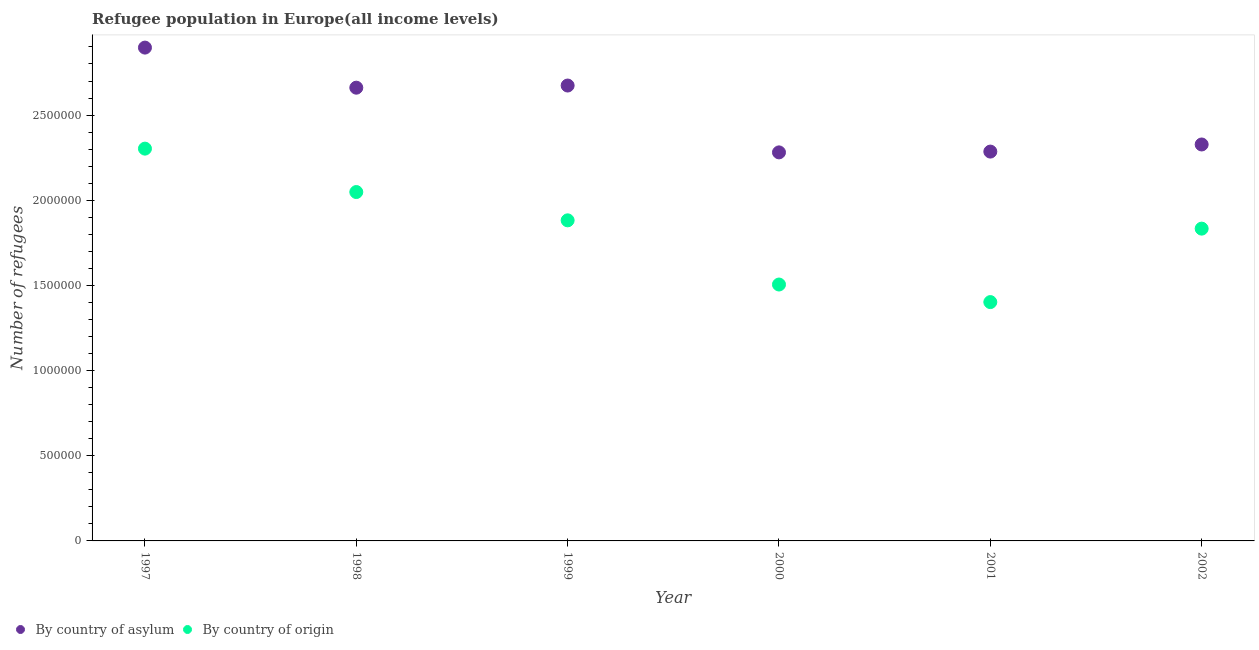What is the number of refugees by country of asylum in 1997?
Provide a short and direct response. 2.90e+06. Across all years, what is the maximum number of refugees by country of asylum?
Offer a very short reply. 2.90e+06. Across all years, what is the minimum number of refugees by country of origin?
Keep it short and to the point. 1.40e+06. What is the total number of refugees by country of origin in the graph?
Provide a short and direct response. 1.10e+07. What is the difference between the number of refugees by country of origin in 1997 and that in 2000?
Ensure brevity in your answer.  7.98e+05. What is the difference between the number of refugees by country of asylum in 2000 and the number of refugees by country of origin in 1998?
Provide a succinct answer. 2.33e+05. What is the average number of refugees by country of asylum per year?
Keep it short and to the point. 2.52e+06. In the year 2002, what is the difference between the number of refugees by country of asylum and number of refugees by country of origin?
Provide a short and direct response. 4.94e+05. In how many years, is the number of refugees by country of asylum greater than 400000?
Make the answer very short. 6. What is the ratio of the number of refugees by country of origin in 1997 to that in 2002?
Your response must be concise. 1.26. Is the difference between the number of refugees by country of asylum in 1998 and 2001 greater than the difference between the number of refugees by country of origin in 1998 and 2001?
Offer a terse response. No. What is the difference between the highest and the second highest number of refugees by country of asylum?
Your answer should be compact. 2.23e+05. What is the difference between the highest and the lowest number of refugees by country of asylum?
Offer a very short reply. 6.15e+05. In how many years, is the number of refugees by country of origin greater than the average number of refugees by country of origin taken over all years?
Ensure brevity in your answer.  4. Is the number of refugees by country of origin strictly greater than the number of refugees by country of asylum over the years?
Provide a succinct answer. No. How many dotlines are there?
Your answer should be compact. 2. How many years are there in the graph?
Keep it short and to the point. 6. What is the difference between two consecutive major ticks on the Y-axis?
Offer a very short reply. 5.00e+05. Are the values on the major ticks of Y-axis written in scientific E-notation?
Offer a terse response. No. Does the graph contain grids?
Give a very brief answer. No. How many legend labels are there?
Your answer should be compact. 2. What is the title of the graph?
Give a very brief answer. Refugee population in Europe(all income levels). Does "Stunting" appear as one of the legend labels in the graph?
Keep it short and to the point. No. What is the label or title of the X-axis?
Provide a short and direct response. Year. What is the label or title of the Y-axis?
Your answer should be compact. Number of refugees. What is the Number of refugees in By country of asylum in 1997?
Ensure brevity in your answer.  2.90e+06. What is the Number of refugees of By country of origin in 1997?
Give a very brief answer. 2.30e+06. What is the Number of refugees of By country of asylum in 1998?
Offer a terse response. 2.66e+06. What is the Number of refugees of By country of origin in 1998?
Provide a short and direct response. 2.05e+06. What is the Number of refugees in By country of asylum in 1999?
Your answer should be compact. 2.67e+06. What is the Number of refugees of By country of origin in 1999?
Offer a terse response. 1.88e+06. What is the Number of refugees in By country of asylum in 2000?
Provide a short and direct response. 2.28e+06. What is the Number of refugees in By country of origin in 2000?
Offer a very short reply. 1.51e+06. What is the Number of refugees of By country of asylum in 2001?
Give a very brief answer. 2.29e+06. What is the Number of refugees of By country of origin in 2001?
Offer a terse response. 1.40e+06. What is the Number of refugees of By country of asylum in 2002?
Ensure brevity in your answer.  2.33e+06. What is the Number of refugees in By country of origin in 2002?
Make the answer very short. 1.83e+06. Across all years, what is the maximum Number of refugees of By country of asylum?
Make the answer very short. 2.90e+06. Across all years, what is the maximum Number of refugees in By country of origin?
Your answer should be compact. 2.30e+06. Across all years, what is the minimum Number of refugees in By country of asylum?
Provide a succinct answer. 2.28e+06. Across all years, what is the minimum Number of refugees of By country of origin?
Provide a succinct answer. 1.40e+06. What is the total Number of refugees in By country of asylum in the graph?
Provide a short and direct response. 1.51e+07. What is the total Number of refugees of By country of origin in the graph?
Ensure brevity in your answer.  1.10e+07. What is the difference between the Number of refugees of By country of asylum in 1997 and that in 1998?
Offer a terse response. 2.35e+05. What is the difference between the Number of refugees in By country of origin in 1997 and that in 1998?
Your answer should be compact. 2.55e+05. What is the difference between the Number of refugees of By country of asylum in 1997 and that in 1999?
Ensure brevity in your answer.  2.23e+05. What is the difference between the Number of refugees in By country of origin in 1997 and that in 1999?
Make the answer very short. 4.21e+05. What is the difference between the Number of refugees of By country of asylum in 1997 and that in 2000?
Give a very brief answer. 6.15e+05. What is the difference between the Number of refugees of By country of origin in 1997 and that in 2000?
Offer a very short reply. 7.98e+05. What is the difference between the Number of refugees of By country of asylum in 1997 and that in 2001?
Give a very brief answer. 6.11e+05. What is the difference between the Number of refugees in By country of origin in 1997 and that in 2001?
Give a very brief answer. 9.01e+05. What is the difference between the Number of refugees of By country of asylum in 1997 and that in 2002?
Provide a short and direct response. 5.69e+05. What is the difference between the Number of refugees in By country of origin in 1997 and that in 2002?
Provide a short and direct response. 4.70e+05. What is the difference between the Number of refugees of By country of asylum in 1998 and that in 1999?
Provide a short and direct response. -1.26e+04. What is the difference between the Number of refugees of By country of origin in 1998 and that in 1999?
Your answer should be very brief. 1.66e+05. What is the difference between the Number of refugees of By country of asylum in 1998 and that in 2000?
Make the answer very short. 3.80e+05. What is the difference between the Number of refugees in By country of origin in 1998 and that in 2000?
Provide a short and direct response. 5.43e+05. What is the difference between the Number of refugees of By country of asylum in 1998 and that in 2001?
Offer a terse response. 3.75e+05. What is the difference between the Number of refugees of By country of origin in 1998 and that in 2001?
Keep it short and to the point. 6.46e+05. What is the difference between the Number of refugees of By country of asylum in 1998 and that in 2002?
Ensure brevity in your answer.  3.33e+05. What is the difference between the Number of refugees of By country of origin in 1998 and that in 2002?
Make the answer very short. 2.15e+05. What is the difference between the Number of refugees of By country of asylum in 1999 and that in 2000?
Offer a very short reply. 3.92e+05. What is the difference between the Number of refugees in By country of origin in 1999 and that in 2000?
Ensure brevity in your answer.  3.77e+05. What is the difference between the Number of refugees of By country of asylum in 1999 and that in 2001?
Your answer should be compact. 3.88e+05. What is the difference between the Number of refugees in By country of origin in 1999 and that in 2001?
Give a very brief answer. 4.80e+05. What is the difference between the Number of refugees in By country of asylum in 1999 and that in 2002?
Make the answer very short. 3.46e+05. What is the difference between the Number of refugees in By country of origin in 1999 and that in 2002?
Ensure brevity in your answer.  4.87e+04. What is the difference between the Number of refugees in By country of asylum in 2000 and that in 2001?
Give a very brief answer. -4639. What is the difference between the Number of refugees of By country of origin in 2000 and that in 2001?
Offer a terse response. 1.03e+05. What is the difference between the Number of refugees of By country of asylum in 2000 and that in 2002?
Keep it short and to the point. -4.64e+04. What is the difference between the Number of refugees of By country of origin in 2000 and that in 2002?
Give a very brief answer. -3.28e+05. What is the difference between the Number of refugees in By country of asylum in 2001 and that in 2002?
Provide a succinct answer. -4.18e+04. What is the difference between the Number of refugees of By country of origin in 2001 and that in 2002?
Your answer should be very brief. -4.31e+05. What is the difference between the Number of refugees of By country of asylum in 1997 and the Number of refugees of By country of origin in 1998?
Provide a succinct answer. 8.48e+05. What is the difference between the Number of refugees of By country of asylum in 1997 and the Number of refugees of By country of origin in 1999?
Keep it short and to the point. 1.01e+06. What is the difference between the Number of refugees of By country of asylum in 1997 and the Number of refugees of By country of origin in 2000?
Your answer should be compact. 1.39e+06. What is the difference between the Number of refugees of By country of asylum in 1997 and the Number of refugees of By country of origin in 2001?
Ensure brevity in your answer.  1.49e+06. What is the difference between the Number of refugees of By country of asylum in 1997 and the Number of refugees of By country of origin in 2002?
Your answer should be very brief. 1.06e+06. What is the difference between the Number of refugees in By country of asylum in 1998 and the Number of refugees in By country of origin in 1999?
Give a very brief answer. 7.79e+05. What is the difference between the Number of refugees of By country of asylum in 1998 and the Number of refugees of By country of origin in 2000?
Make the answer very short. 1.16e+06. What is the difference between the Number of refugees in By country of asylum in 1998 and the Number of refugees in By country of origin in 2001?
Give a very brief answer. 1.26e+06. What is the difference between the Number of refugees of By country of asylum in 1998 and the Number of refugees of By country of origin in 2002?
Offer a terse response. 8.28e+05. What is the difference between the Number of refugees in By country of asylum in 1999 and the Number of refugees in By country of origin in 2000?
Offer a very short reply. 1.17e+06. What is the difference between the Number of refugees of By country of asylum in 1999 and the Number of refugees of By country of origin in 2001?
Your answer should be compact. 1.27e+06. What is the difference between the Number of refugees in By country of asylum in 1999 and the Number of refugees in By country of origin in 2002?
Give a very brief answer. 8.40e+05. What is the difference between the Number of refugees in By country of asylum in 2000 and the Number of refugees in By country of origin in 2001?
Offer a very short reply. 8.79e+05. What is the difference between the Number of refugees in By country of asylum in 2000 and the Number of refugees in By country of origin in 2002?
Give a very brief answer. 4.48e+05. What is the difference between the Number of refugees in By country of asylum in 2001 and the Number of refugees in By country of origin in 2002?
Your response must be concise. 4.52e+05. What is the average Number of refugees of By country of asylum per year?
Offer a terse response. 2.52e+06. What is the average Number of refugees of By country of origin per year?
Give a very brief answer. 1.83e+06. In the year 1997, what is the difference between the Number of refugees of By country of asylum and Number of refugees of By country of origin?
Your answer should be compact. 5.93e+05. In the year 1998, what is the difference between the Number of refugees in By country of asylum and Number of refugees in By country of origin?
Ensure brevity in your answer.  6.13e+05. In the year 1999, what is the difference between the Number of refugees of By country of asylum and Number of refugees of By country of origin?
Keep it short and to the point. 7.91e+05. In the year 2000, what is the difference between the Number of refugees in By country of asylum and Number of refugees in By country of origin?
Provide a short and direct response. 7.76e+05. In the year 2001, what is the difference between the Number of refugees of By country of asylum and Number of refugees of By country of origin?
Make the answer very short. 8.84e+05. In the year 2002, what is the difference between the Number of refugees in By country of asylum and Number of refugees in By country of origin?
Keep it short and to the point. 4.94e+05. What is the ratio of the Number of refugees in By country of asylum in 1997 to that in 1998?
Give a very brief answer. 1.09. What is the ratio of the Number of refugees in By country of origin in 1997 to that in 1998?
Give a very brief answer. 1.12. What is the ratio of the Number of refugees of By country of origin in 1997 to that in 1999?
Provide a succinct answer. 1.22. What is the ratio of the Number of refugees of By country of asylum in 1997 to that in 2000?
Your answer should be compact. 1.27. What is the ratio of the Number of refugees of By country of origin in 1997 to that in 2000?
Offer a terse response. 1.53. What is the ratio of the Number of refugees in By country of asylum in 1997 to that in 2001?
Your answer should be compact. 1.27. What is the ratio of the Number of refugees of By country of origin in 1997 to that in 2001?
Give a very brief answer. 1.64. What is the ratio of the Number of refugees of By country of asylum in 1997 to that in 2002?
Your answer should be compact. 1.24. What is the ratio of the Number of refugees of By country of origin in 1997 to that in 2002?
Offer a terse response. 1.26. What is the ratio of the Number of refugees in By country of asylum in 1998 to that in 1999?
Offer a very short reply. 1. What is the ratio of the Number of refugees of By country of origin in 1998 to that in 1999?
Provide a short and direct response. 1.09. What is the ratio of the Number of refugees in By country of asylum in 1998 to that in 2000?
Ensure brevity in your answer.  1.17. What is the ratio of the Number of refugees in By country of origin in 1998 to that in 2000?
Offer a terse response. 1.36. What is the ratio of the Number of refugees of By country of asylum in 1998 to that in 2001?
Keep it short and to the point. 1.16. What is the ratio of the Number of refugees in By country of origin in 1998 to that in 2001?
Keep it short and to the point. 1.46. What is the ratio of the Number of refugees of By country of asylum in 1998 to that in 2002?
Your answer should be compact. 1.14. What is the ratio of the Number of refugees of By country of origin in 1998 to that in 2002?
Your response must be concise. 1.12. What is the ratio of the Number of refugees of By country of asylum in 1999 to that in 2000?
Provide a succinct answer. 1.17. What is the ratio of the Number of refugees of By country of origin in 1999 to that in 2000?
Provide a short and direct response. 1.25. What is the ratio of the Number of refugees of By country of asylum in 1999 to that in 2001?
Provide a short and direct response. 1.17. What is the ratio of the Number of refugees of By country of origin in 1999 to that in 2001?
Your answer should be compact. 1.34. What is the ratio of the Number of refugees in By country of asylum in 1999 to that in 2002?
Your response must be concise. 1.15. What is the ratio of the Number of refugees of By country of origin in 1999 to that in 2002?
Your answer should be compact. 1.03. What is the ratio of the Number of refugees in By country of asylum in 2000 to that in 2001?
Offer a very short reply. 1. What is the ratio of the Number of refugees of By country of origin in 2000 to that in 2001?
Keep it short and to the point. 1.07. What is the ratio of the Number of refugees in By country of asylum in 2000 to that in 2002?
Ensure brevity in your answer.  0.98. What is the ratio of the Number of refugees in By country of origin in 2000 to that in 2002?
Your response must be concise. 0.82. What is the ratio of the Number of refugees of By country of asylum in 2001 to that in 2002?
Your answer should be very brief. 0.98. What is the ratio of the Number of refugees in By country of origin in 2001 to that in 2002?
Make the answer very short. 0.76. What is the difference between the highest and the second highest Number of refugees of By country of asylum?
Offer a terse response. 2.23e+05. What is the difference between the highest and the second highest Number of refugees of By country of origin?
Offer a very short reply. 2.55e+05. What is the difference between the highest and the lowest Number of refugees in By country of asylum?
Give a very brief answer. 6.15e+05. What is the difference between the highest and the lowest Number of refugees of By country of origin?
Your answer should be compact. 9.01e+05. 